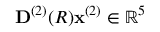Convert formula to latex. <formula><loc_0><loc_0><loc_500><loc_500>D ^ { ( 2 ) } ( R ) x ^ { ( 2 ) } \in \mathbb { R } ^ { 5 }</formula> 